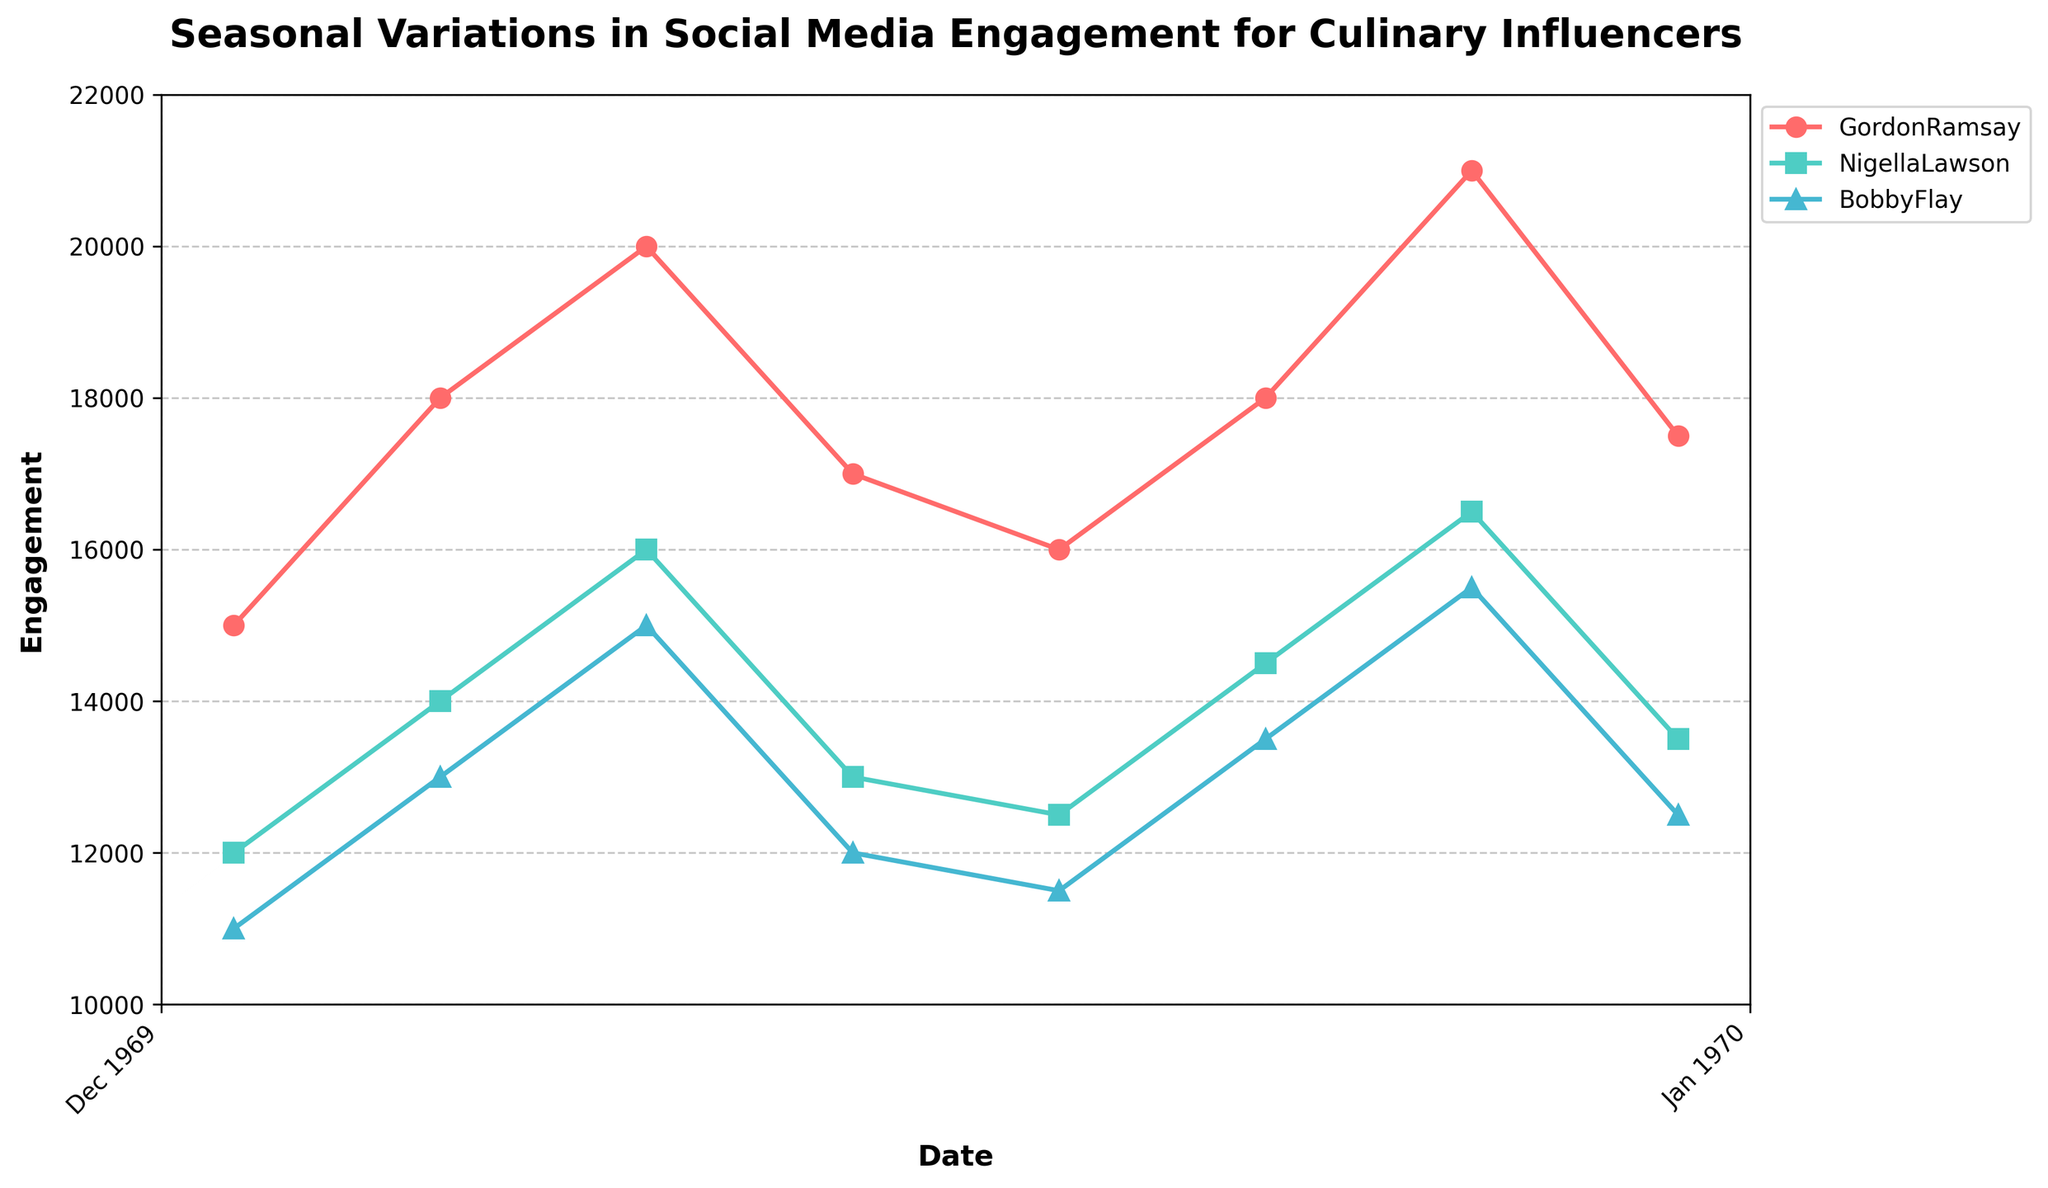What is the title of the plot? The title of the plot is usually displayed at the top, and it is labeled to give an overview of the chart. Here, it reads "Seasonal Variations in Social Media Engagement for Culinary Influencers."
Answer: Seasonal Variations in Social Media Engagement for Culinary Influencers What is the engagement value for Gordon Ramsay in January 2023? To find this, look for the data point corresponding to January 2023 for Gordon Ramsay's series on the plot. The value is labeled directly on the y-axis.
Answer: 16000 Which influencer has the highest engagement in July 2023? To answer this, compare the engagement values of all influencers in July 2023. The highest point on the y-axis for this month belongs to Gordon Ramsay.
Answer: Gordon Ramsay How many influencers are plotted in the figure? Count the number of different colors and markers in the plot, which represent different influencers. The legend also helps in identifying them.
Answer: 3 What are the colors used to represent each influencer? Observe the color legend or the color of the lines and markers in the plot. Gordon Ramsay is red, Nigella Lawson is teal, and Bobby Flay is blue.
Answer: Red, Teal, Blue Which season tends to have the highest engagement for Gordon Ramsay? By inspecting the plot, note which periods/seasons have the highest peaks in Gordon Ramsay's engagement line. The summer season (July) shows the highest engagement.
Answer: Summer What is the difference in engagement between Bobby Flay and Nigella Lawson in October 2023? Locate the engagement values for both influencers in October 2023 and subtract the smaller from the larger value. Bobby Flay has 12500 and Nigella Lawson has 13500, so the difference is 13500 - 12500 = 1000.
Answer: 1000 Which influencer showed the most significant increase in engagement between January 2022 and July 2023? Calculate the difference in engagement between January 2022 and July 2023 for each influencer. Gordon Ramsay increased from 15000 to 21000 (6000 increase), Nigella Lawson from 12000 to 16500 (4500 increase), and Bobby Flay from 11000 to 15500 (4500 increase). The largest increase is Gordon Ramsay's 6000.
Answer: Gordon Ramsay What trend can be seen in Bobby Flay's engagement from July 2022 to October 2022? Inspect Bobby Flay’s engagement line between these two points. It shows a decline in engagement.
Answer: Decline Is there a consistent pattern in engagement for any of the influencers across the two years? Examine the engagement trends throughout the different seasons for both years for each influencer. Gordon Ramsay shows consistent peaks in engagement during the summer months of both years.
Answer: Yes, Gordon Ramsay in summer 